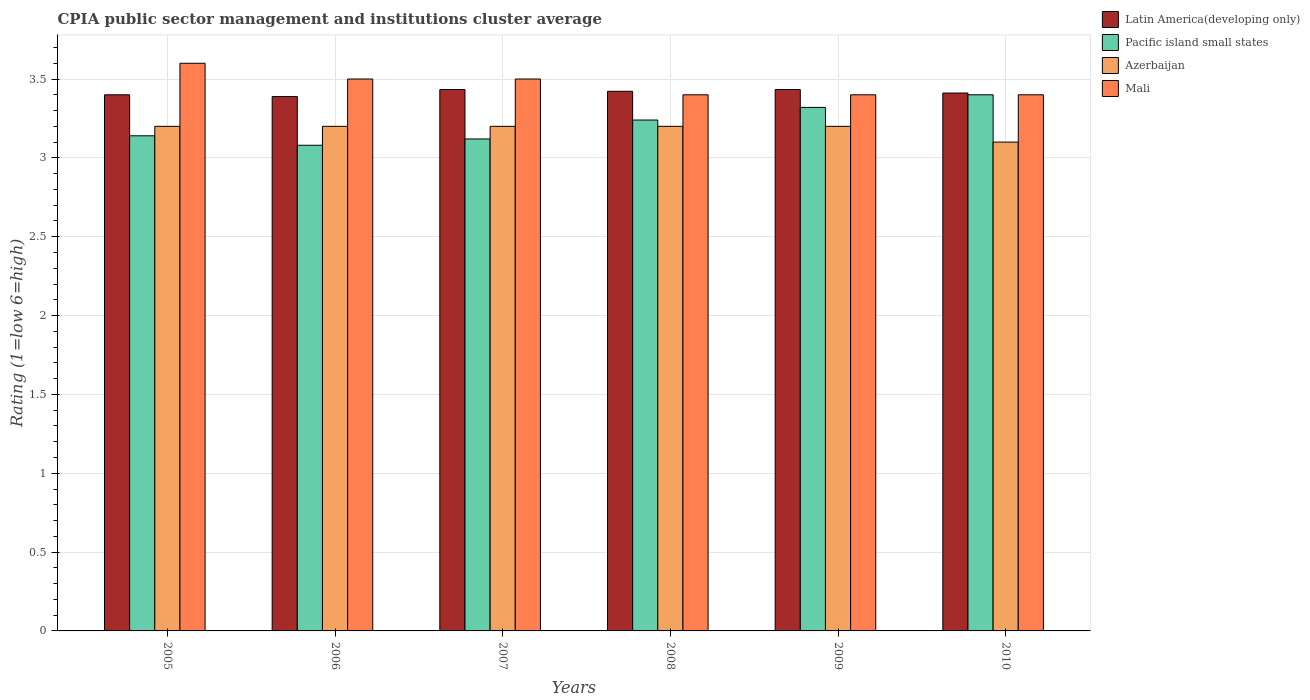How many different coloured bars are there?
Provide a short and direct response. 4. How many groups of bars are there?
Make the answer very short. 6. Are the number of bars on each tick of the X-axis equal?
Your response must be concise. Yes. What is the label of the 1st group of bars from the left?
Your answer should be compact. 2005. In how many cases, is the number of bars for a given year not equal to the number of legend labels?
Your answer should be very brief. 0. What is the CPIA rating in Pacific island small states in 2005?
Offer a very short reply. 3.14. Across all years, what is the maximum CPIA rating in Latin America(developing only)?
Provide a succinct answer. 3.43. Across all years, what is the minimum CPIA rating in Pacific island small states?
Your answer should be very brief. 3.08. In which year was the CPIA rating in Azerbaijan maximum?
Your answer should be very brief. 2005. In which year was the CPIA rating in Mali minimum?
Provide a succinct answer. 2008. What is the total CPIA rating in Latin America(developing only) in the graph?
Your answer should be very brief. 20.49. What is the difference between the CPIA rating in Mali in 2007 and that in 2010?
Provide a short and direct response. 0.1. What is the difference between the CPIA rating in Azerbaijan in 2008 and the CPIA rating in Latin America(developing only) in 2010?
Offer a very short reply. -0.21. What is the average CPIA rating in Latin America(developing only) per year?
Your answer should be compact. 3.41. In the year 2008, what is the difference between the CPIA rating in Latin America(developing only) and CPIA rating in Pacific island small states?
Keep it short and to the point. 0.18. In how many years, is the CPIA rating in Mali greater than 0.1?
Provide a short and direct response. 6. What is the ratio of the CPIA rating in Pacific island small states in 2005 to that in 2008?
Give a very brief answer. 0.97. Is the CPIA rating in Pacific island small states in 2006 less than that in 2010?
Provide a short and direct response. Yes. Is the difference between the CPIA rating in Latin America(developing only) in 2008 and 2010 greater than the difference between the CPIA rating in Pacific island small states in 2008 and 2010?
Your answer should be very brief. Yes. What is the difference between the highest and the second highest CPIA rating in Mali?
Offer a terse response. 0.1. What is the difference between the highest and the lowest CPIA rating in Latin America(developing only)?
Your answer should be very brief. 0.04. In how many years, is the CPIA rating in Pacific island small states greater than the average CPIA rating in Pacific island small states taken over all years?
Your response must be concise. 3. Is it the case that in every year, the sum of the CPIA rating in Mali and CPIA rating in Pacific island small states is greater than the sum of CPIA rating in Latin America(developing only) and CPIA rating in Azerbaijan?
Give a very brief answer. No. What does the 4th bar from the left in 2009 represents?
Give a very brief answer. Mali. What does the 2nd bar from the right in 2010 represents?
Provide a succinct answer. Azerbaijan. How many bars are there?
Make the answer very short. 24. Are all the bars in the graph horizontal?
Give a very brief answer. No. How many years are there in the graph?
Offer a terse response. 6. What is the difference between two consecutive major ticks on the Y-axis?
Keep it short and to the point. 0.5. How are the legend labels stacked?
Ensure brevity in your answer.  Vertical. What is the title of the graph?
Ensure brevity in your answer.  CPIA public sector management and institutions cluster average. What is the label or title of the X-axis?
Ensure brevity in your answer.  Years. What is the label or title of the Y-axis?
Offer a very short reply. Rating (1=low 6=high). What is the Rating (1=low 6=high) of Latin America(developing only) in 2005?
Your answer should be compact. 3.4. What is the Rating (1=low 6=high) of Pacific island small states in 2005?
Provide a short and direct response. 3.14. What is the Rating (1=low 6=high) of Latin America(developing only) in 2006?
Your answer should be compact. 3.39. What is the Rating (1=low 6=high) in Pacific island small states in 2006?
Ensure brevity in your answer.  3.08. What is the Rating (1=low 6=high) in Latin America(developing only) in 2007?
Your response must be concise. 3.43. What is the Rating (1=low 6=high) of Pacific island small states in 2007?
Provide a short and direct response. 3.12. What is the Rating (1=low 6=high) in Latin America(developing only) in 2008?
Your answer should be compact. 3.42. What is the Rating (1=low 6=high) in Pacific island small states in 2008?
Provide a succinct answer. 3.24. What is the Rating (1=low 6=high) in Azerbaijan in 2008?
Give a very brief answer. 3.2. What is the Rating (1=low 6=high) in Latin America(developing only) in 2009?
Offer a terse response. 3.43. What is the Rating (1=low 6=high) in Pacific island small states in 2009?
Offer a terse response. 3.32. What is the Rating (1=low 6=high) of Azerbaijan in 2009?
Offer a terse response. 3.2. What is the Rating (1=low 6=high) of Latin America(developing only) in 2010?
Your answer should be very brief. 3.41. What is the Rating (1=low 6=high) of Pacific island small states in 2010?
Make the answer very short. 3.4. What is the Rating (1=low 6=high) of Azerbaijan in 2010?
Offer a terse response. 3.1. What is the Rating (1=low 6=high) in Mali in 2010?
Offer a terse response. 3.4. Across all years, what is the maximum Rating (1=low 6=high) of Latin America(developing only)?
Give a very brief answer. 3.43. Across all years, what is the maximum Rating (1=low 6=high) of Azerbaijan?
Offer a terse response. 3.2. Across all years, what is the minimum Rating (1=low 6=high) of Latin America(developing only)?
Your answer should be very brief. 3.39. Across all years, what is the minimum Rating (1=low 6=high) in Pacific island small states?
Offer a very short reply. 3.08. Across all years, what is the minimum Rating (1=low 6=high) of Azerbaijan?
Provide a succinct answer. 3.1. What is the total Rating (1=low 6=high) of Latin America(developing only) in the graph?
Your answer should be very brief. 20.49. What is the total Rating (1=low 6=high) of Pacific island small states in the graph?
Provide a succinct answer. 19.3. What is the total Rating (1=low 6=high) of Mali in the graph?
Offer a terse response. 20.8. What is the difference between the Rating (1=low 6=high) of Latin America(developing only) in 2005 and that in 2006?
Make the answer very short. 0.01. What is the difference between the Rating (1=low 6=high) in Pacific island small states in 2005 and that in 2006?
Keep it short and to the point. 0.06. What is the difference between the Rating (1=low 6=high) in Latin America(developing only) in 2005 and that in 2007?
Give a very brief answer. -0.03. What is the difference between the Rating (1=low 6=high) of Pacific island small states in 2005 and that in 2007?
Ensure brevity in your answer.  0.02. What is the difference between the Rating (1=low 6=high) in Azerbaijan in 2005 and that in 2007?
Provide a short and direct response. 0. What is the difference between the Rating (1=low 6=high) in Mali in 2005 and that in 2007?
Offer a terse response. 0.1. What is the difference between the Rating (1=low 6=high) in Latin America(developing only) in 2005 and that in 2008?
Your response must be concise. -0.02. What is the difference between the Rating (1=low 6=high) in Pacific island small states in 2005 and that in 2008?
Offer a very short reply. -0.1. What is the difference between the Rating (1=low 6=high) of Azerbaijan in 2005 and that in 2008?
Give a very brief answer. 0. What is the difference between the Rating (1=low 6=high) of Mali in 2005 and that in 2008?
Offer a very short reply. 0.2. What is the difference between the Rating (1=low 6=high) in Latin America(developing only) in 2005 and that in 2009?
Keep it short and to the point. -0.03. What is the difference between the Rating (1=low 6=high) of Pacific island small states in 2005 and that in 2009?
Your answer should be very brief. -0.18. What is the difference between the Rating (1=low 6=high) in Azerbaijan in 2005 and that in 2009?
Give a very brief answer. 0. What is the difference between the Rating (1=low 6=high) in Latin America(developing only) in 2005 and that in 2010?
Your answer should be compact. -0.01. What is the difference between the Rating (1=low 6=high) in Pacific island small states in 2005 and that in 2010?
Offer a very short reply. -0.26. What is the difference between the Rating (1=low 6=high) of Azerbaijan in 2005 and that in 2010?
Give a very brief answer. 0.1. What is the difference between the Rating (1=low 6=high) of Mali in 2005 and that in 2010?
Your answer should be compact. 0.2. What is the difference between the Rating (1=low 6=high) in Latin America(developing only) in 2006 and that in 2007?
Keep it short and to the point. -0.04. What is the difference between the Rating (1=low 6=high) of Pacific island small states in 2006 and that in 2007?
Keep it short and to the point. -0.04. What is the difference between the Rating (1=low 6=high) in Azerbaijan in 2006 and that in 2007?
Your answer should be compact. 0. What is the difference between the Rating (1=low 6=high) in Latin America(developing only) in 2006 and that in 2008?
Offer a very short reply. -0.03. What is the difference between the Rating (1=low 6=high) in Pacific island small states in 2006 and that in 2008?
Provide a succinct answer. -0.16. What is the difference between the Rating (1=low 6=high) of Mali in 2006 and that in 2008?
Provide a succinct answer. 0.1. What is the difference between the Rating (1=low 6=high) in Latin America(developing only) in 2006 and that in 2009?
Offer a very short reply. -0.04. What is the difference between the Rating (1=low 6=high) of Pacific island small states in 2006 and that in 2009?
Provide a succinct answer. -0.24. What is the difference between the Rating (1=low 6=high) in Azerbaijan in 2006 and that in 2009?
Give a very brief answer. 0. What is the difference between the Rating (1=low 6=high) of Latin America(developing only) in 2006 and that in 2010?
Provide a short and direct response. -0.02. What is the difference between the Rating (1=low 6=high) of Pacific island small states in 2006 and that in 2010?
Ensure brevity in your answer.  -0.32. What is the difference between the Rating (1=low 6=high) of Latin America(developing only) in 2007 and that in 2008?
Provide a short and direct response. 0.01. What is the difference between the Rating (1=low 6=high) in Pacific island small states in 2007 and that in 2008?
Your response must be concise. -0.12. What is the difference between the Rating (1=low 6=high) of Mali in 2007 and that in 2008?
Provide a succinct answer. 0.1. What is the difference between the Rating (1=low 6=high) in Latin America(developing only) in 2007 and that in 2009?
Provide a succinct answer. 0. What is the difference between the Rating (1=low 6=high) in Mali in 2007 and that in 2009?
Ensure brevity in your answer.  0.1. What is the difference between the Rating (1=low 6=high) in Latin America(developing only) in 2007 and that in 2010?
Ensure brevity in your answer.  0.02. What is the difference between the Rating (1=low 6=high) in Pacific island small states in 2007 and that in 2010?
Keep it short and to the point. -0.28. What is the difference between the Rating (1=low 6=high) in Mali in 2007 and that in 2010?
Your response must be concise. 0.1. What is the difference between the Rating (1=low 6=high) in Latin America(developing only) in 2008 and that in 2009?
Ensure brevity in your answer.  -0.01. What is the difference between the Rating (1=low 6=high) in Pacific island small states in 2008 and that in 2009?
Provide a short and direct response. -0.08. What is the difference between the Rating (1=low 6=high) of Latin America(developing only) in 2008 and that in 2010?
Your answer should be very brief. 0.01. What is the difference between the Rating (1=low 6=high) of Pacific island small states in 2008 and that in 2010?
Your answer should be very brief. -0.16. What is the difference between the Rating (1=low 6=high) of Azerbaijan in 2008 and that in 2010?
Keep it short and to the point. 0.1. What is the difference between the Rating (1=low 6=high) in Latin America(developing only) in 2009 and that in 2010?
Your response must be concise. 0.02. What is the difference between the Rating (1=low 6=high) in Pacific island small states in 2009 and that in 2010?
Give a very brief answer. -0.08. What is the difference between the Rating (1=low 6=high) of Latin America(developing only) in 2005 and the Rating (1=low 6=high) of Pacific island small states in 2006?
Provide a succinct answer. 0.32. What is the difference between the Rating (1=low 6=high) in Latin America(developing only) in 2005 and the Rating (1=low 6=high) in Azerbaijan in 2006?
Offer a terse response. 0.2. What is the difference between the Rating (1=low 6=high) in Latin America(developing only) in 2005 and the Rating (1=low 6=high) in Mali in 2006?
Provide a short and direct response. -0.1. What is the difference between the Rating (1=low 6=high) of Pacific island small states in 2005 and the Rating (1=low 6=high) of Azerbaijan in 2006?
Keep it short and to the point. -0.06. What is the difference between the Rating (1=low 6=high) in Pacific island small states in 2005 and the Rating (1=low 6=high) in Mali in 2006?
Keep it short and to the point. -0.36. What is the difference between the Rating (1=low 6=high) of Latin America(developing only) in 2005 and the Rating (1=low 6=high) of Pacific island small states in 2007?
Provide a short and direct response. 0.28. What is the difference between the Rating (1=low 6=high) of Latin America(developing only) in 2005 and the Rating (1=low 6=high) of Mali in 2007?
Provide a succinct answer. -0.1. What is the difference between the Rating (1=low 6=high) in Pacific island small states in 2005 and the Rating (1=low 6=high) in Azerbaijan in 2007?
Give a very brief answer. -0.06. What is the difference between the Rating (1=low 6=high) of Pacific island small states in 2005 and the Rating (1=low 6=high) of Mali in 2007?
Provide a short and direct response. -0.36. What is the difference between the Rating (1=low 6=high) in Azerbaijan in 2005 and the Rating (1=low 6=high) in Mali in 2007?
Make the answer very short. -0.3. What is the difference between the Rating (1=low 6=high) of Latin America(developing only) in 2005 and the Rating (1=low 6=high) of Pacific island small states in 2008?
Your response must be concise. 0.16. What is the difference between the Rating (1=low 6=high) in Pacific island small states in 2005 and the Rating (1=low 6=high) in Azerbaijan in 2008?
Provide a short and direct response. -0.06. What is the difference between the Rating (1=low 6=high) of Pacific island small states in 2005 and the Rating (1=low 6=high) of Mali in 2008?
Provide a short and direct response. -0.26. What is the difference between the Rating (1=low 6=high) of Latin America(developing only) in 2005 and the Rating (1=low 6=high) of Pacific island small states in 2009?
Give a very brief answer. 0.08. What is the difference between the Rating (1=low 6=high) of Latin America(developing only) in 2005 and the Rating (1=low 6=high) of Mali in 2009?
Keep it short and to the point. 0. What is the difference between the Rating (1=low 6=high) in Pacific island small states in 2005 and the Rating (1=low 6=high) in Azerbaijan in 2009?
Offer a terse response. -0.06. What is the difference between the Rating (1=low 6=high) of Pacific island small states in 2005 and the Rating (1=low 6=high) of Mali in 2009?
Make the answer very short. -0.26. What is the difference between the Rating (1=low 6=high) of Latin America(developing only) in 2005 and the Rating (1=low 6=high) of Pacific island small states in 2010?
Your answer should be very brief. 0. What is the difference between the Rating (1=low 6=high) of Latin America(developing only) in 2005 and the Rating (1=low 6=high) of Azerbaijan in 2010?
Offer a terse response. 0.3. What is the difference between the Rating (1=low 6=high) in Pacific island small states in 2005 and the Rating (1=low 6=high) in Azerbaijan in 2010?
Your answer should be compact. 0.04. What is the difference between the Rating (1=low 6=high) in Pacific island small states in 2005 and the Rating (1=low 6=high) in Mali in 2010?
Your response must be concise. -0.26. What is the difference between the Rating (1=low 6=high) in Azerbaijan in 2005 and the Rating (1=low 6=high) in Mali in 2010?
Keep it short and to the point. -0.2. What is the difference between the Rating (1=low 6=high) in Latin America(developing only) in 2006 and the Rating (1=low 6=high) in Pacific island small states in 2007?
Ensure brevity in your answer.  0.27. What is the difference between the Rating (1=low 6=high) of Latin America(developing only) in 2006 and the Rating (1=low 6=high) of Azerbaijan in 2007?
Provide a succinct answer. 0.19. What is the difference between the Rating (1=low 6=high) of Latin America(developing only) in 2006 and the Rating (1=low 6=high) of Mali in 2007?
Your answer should be compact. -0.11. What is the difference between the Rating (1=low 6=high) of Pacific island small states in 2006 and the Rating (1=low 6=high) of Azerbaijan in 2007?
Your response must be concise. -0.12. What is the difference between the Rating (1=low 6=high) in Pacific island small states in 2006 and the Rating (1=low 6=high) in Mali in 2007?
Provide a succinct answer. -0.42. What is the difference between the Rating (1=low 6=high) in Latin America(developing only) in 2006 and the Rating (1=low 6=high) in Pacific island small states in 2008?
Offer a terse response. 0.15. What is the difference between the Rating (1=low 6=high) in Latin America(developing only) in 2006 and the Rating (1=low 6=high) in Azerbaijan in 2008?
Your response must be concise. 0.19. What is the difference between the Rating (1=low 6=high) in Latin America(developing only) in 2006 and the Rating (1=low 6=high) in Mali in 2008?
Make the answer very short. -0.01. What is the difference between the Rating (1=low 6=high) of Pacific island small states in 2006 and the Rating (1=low 6=high) of Azerbaijan in 2008?
Your answer should be very brief. -0.12. What is the difference between the Rating (1=low 6=high) of Pacific island small states in 2006 and the Rating (1=low 6=high) of Mali in 2008?
Keep it short and to the point. -0.32. What is the difference between the Rating (1=low 6=high) in Azerbaijan in 2006 and the Rating (1=low 6=high) in Mali in 2008?
Offer a very short reply. -0.2. What is the difference between the Rating (1=low 6=high) of Latin America(developing only) in 2006 and the Rating (1=low 6=high) of Pacific island small states in 2009?
Offer a terse response. 0.07. What is the difference between the Rating (1=low 6=high) in Latin America(developing only) in 2006 and the Rating (1=low 6=high) in Azerbaijan in 2009?
Your answer should be very brief. 0.19. What is the difference between the Rating (1=low 6=high) in Latin America(developing only) in 2006 and the Rating (1=low 6=high) in Mali in 2009?
Ensure brevity in your answer.  -0.01. What is the difference between the Rating (1=low 6=high) of Pacific island small states in 2006 and the Rating (1=low 6=high) of Azerbaijan in 2009?
Provide a succinct answer. -0.12. What is the difference between the Rating (1=low 6=high) of Pacific island small states in 2006 and the Rating (1=low 6=high) of Mali in 2009?
Your answer should be compact. -0.32. What is the difference between the Rating (1=low 6=high) in Azerbaijan in 2006 and the Rating (1=low 6=high) in Mali in 2009?
Ensure brevity in your answer.  -0.2. What is the difference between the Rating (1=low 6=high) of Latin America(developing only) in 2006 and the Rating (1=low 6=high) of Pacific island small states in 2010?
Ensure brevity in your answer.  -0.01. What is the difference between the Rating (1=low 6=high) of Latin America(developing only) in 2006 and the Rating (1=low 6=high) of Azerbaijan in 2010?
Offer a very short reply. 0.29. What is the difference between the Rating (1=low 6=high) in Latin America(developing only) in 2006 and the Rating (1=low 6=high) in Mali in 2010?
Provide a succinct answer. -0.01. What is the difference between the Rating (1=low 6=high) of Pacific island small states in 2006 and the Rating (1=low 6=high) of Azerbaijan in 2010?
Keep it short and to the point. -0.02. What is the difference between the Rating (1=low 6=high) in Pacific island small states in 2006 and the Rating (1=low 6=high) in Mali in 2010?
Your answer should be compact. -0.32. What is the difference between the Rating (1=low 6=high) of Azerbaijan in 2006 and the Rating (1=low 6=high) of Mali in 2010?
Make the answer very short. -0.2. What is the difference between the Rating (1=low 6=high) of Latin America(developing only) in 2007 and the Rating (1=low 6=high) of Pacific island small states in 2008?
Your answer should be compact. 0.19. What is the difference between the Rating (1=low 6=high) in Latin America(developing only) in 2007 and the Rating (1=low 6=high) in Azerbaijan in 2008?
Offer a terse response. 0.23. What is the difference between the Rating (1=low 6=high) in Pacific island small states in 2007 and the Rating (1=low 6=high) in Azerbaijan in 2008?
Provide a short and direct response. -0.08. What is the difference between the Rating (1=low 6=high) of Pacific island small states in 2007 and the Rating (1=low 6=high) of Mali in 2008?
Keep it short and to the point. -0.28. What is the difference between the Rating (1=low 6=high) of Latin America(developing only) in 2007 and the Rating (1=low 6=high) of Pacific island small states in 2009?
Your response must be concise. 0.11. What is the difference between the Rating (1=low 6=high) in Latin America(developing only) in 2007 and the Rating (1=low 6=high) in Azerbaijan in 2009?
Provide a short and direct response. 0.23. What is the difference between the Rating (1=low 6=high) of Pacific island small states in 2007 and the Rating (1=low 6=high) of Azerbaijan in 2009?
Provide a succinct answer. -0.08. What is the difference between the Rating (1=low 6=high) in Pacific island small states in 2007 and the Rating (1=low 6=high) in Mali in 2009?
Provide a succinct answer. -0.28. What is the difference between the Rating (1=low 6=high) in Latin America(developing only) in 2007 and the Rating (1=low 6=high) in Pacific island small states in 2010?
Make the answer very short. 0.03. What is the difference between the Rating (1=low 6=high) in Pacific island small states in 2007 and the Rating (1=low 6=high) in Azerbaijan in 2010?
Your answer should be compact. 0.02. What is the difference between the Rating (1=low 6=high) of Pacific island small states in 2007 and the Rating (1=low 6=high) of Mali in 2010?
Offer a very short reply. -0.28. What is the difference between the Rating (1=low 6=high) in Latin America(developing only) in 2008 and the Rating (1=low 6=high) in Pacific island small states in 2009?
Give a very brief answer. 0.1. What is the difference between the Rating (1=low 6=high) of Latin America(developing only) in 2008 and the Rating (1=low 6=high) of Azerbaijan in 2009?
Your answer should be very brief. 0.22. What is the difference between the Rating (1=low 6=high) of Latin America(developing only) in 2008 and the Rating (1=low 6=high) of Mali in 2009?
Give a very brief answer. 0.02. What is the difference between the Rating (1=low 6=high) of Pacific island small states in 2008 and the Rating (1=low 6=high) of Azerbaijan in 2009?
Your answer should be very brief. 0.04. What is the difference between the Rating (1=low 6=high) in Pacific island small states in 2008 and the Rating (1=low 6=high) in Mali in 2009?
Provide a succinct answer. -0.16. What is the difference between the Rating (1=low 6=high) in Azerbaijan in 2008 and the Rating (1=low 6=high) in Mali in 2009?
Ensure brevity in your answer.  -0.2. What is the difference between the Rating (1=low 6=high) of Latin America(developing only) in 2008 and the Rating (1=low 6=high) of Pacific island small states in 2010?
Make the answer very short. 0.02. What is the difference between the Rating (1=low 6=high) of Latin America(developing only) in 2008 and the Rating (1=low 6=high) of Azerbaijan in 2010?
Your answer should be compact. 0.32. What is the difference between the Rating (1=low 6=high) in Latin America(developing only) in 2008 and the Rating (1=low 6=high) in Mali in 2010?
Keep it short and to the point. 0.02. What is the difference between the Rating (1=low 6=high) of Pacific island small states in 2008 and the Rating (1=low 6=high) of Azerbaijan in 2010?
Give a very brief answer. 0.14. What is the difference between the Rating (1=low 6=high) in Pacific island small states in 2008 and the Rating (1=low 6=high) in Mali in 2010?
Offer a terse response. -0.16. What is the difference between the Rating (1=low 6=high) of Latin America(developing only) in 2009 and the Rating (1=low 6=high) of Azerbaijan in 2010?
Provide a succinct answer. 0.33. What is the difference between the Rating (1=low 6=high) in Pacific island small states in 2009 and the Rating (1=low 6=high) in Azerbaijan in 2010?
Make the answer very short. 0.22. What is the difference between the Rating (1=low 6=high) of Pacific island small states in 2009 and the Rating (1=low 6=high) of Mali in 2010?
Give a very brief answer. -0.08. What is the average Rating (1=low 6=high) of Latin America(developing only) per year?
Make the answer very short. 3.41. What is the average Rating (1=low 6=high) in Pacific island small states per year?
Give a very brief answer. 3.22. What is the average Rating (1=low 6=high) in Azerbaijan per year?
Give a very brief answer. 3.18. What is the average Rating (1=low 6=high) in Mali per year?
Offer a very short reply. 3.47. In the year 2005, what is the difference between the Rating (1=low 6=high) of Latin America(developing only) and Rating (1=low 6=high) of Pacific island small states?
Ensure brevity in your answer.  0.26. In the year 2005, what is the difference between the Rating (1=low 6=high) in Latin America(developing only) and Rating (1=low 6=high) in Azerbaijan?
Your response must be concise. 0.2. In the year 2005, what is the difference between the Rating (1=low 6=high) of Latin America(developing only) and Rating (1=low 6=high) of Mali?
Your answer should be compact. -0.2. In the year 2005, what is the difference between the Rating (1=low 6=high) of Pacific island small states and Rating (1=low 6=high) of Azerbaijan?
Give a very brief answer. -0.06. In the year 2005, what is the difference between the Rating (1=low 6=high) of Pacific island small states and Rating (1=low 6=high) of Mali?
Offer a terse response. -0.46. In the year 2006, what is the difference between the Rating (1=low 6=high) in Latin America(developing only) and Rating (1=low 6=high) in Pacific island small states?
Your answer should be very brief. 0.31. In the year 2006, what is the difference between the Rating (1=low 6=high) in Latin America(developing only) and Rating (1=low 6=high) in Azerbaijan?
Your response must be concise. 0.19. In the year 2006, what is the difference between the Rating (1=low 6=high) of Latin America(developing only) and Rating (1=low 6=high) of Mali?
Provide a short and direct response. -0.11. In the year 2006, what is the difference between the Rating (1=low 6=high) of Pacific island small states and Rating (1=low 6=high) of Azerbaijan?
Give a very brief answer. -0.12. In the year 2006, what is the difference between the Rating (1=low 6=high) in Pacific island small states and Rating (1=low 6=high) in Mali?
Keep it short and to the point. -0.42. In the year 2006, what is the difference between the Rating (1=low 6=high) of Azerbaijan and Rating (1=low 6=high) of Mali?
Your answer should be very brief. -0.3. In the year 2007, what is the difference between the Rating (1=low 6=high) in Latin America(developing only) and Rating (1=low 6=high) in Pacific island small states?
Keep it short and to the point. 0.31. In the year 2007, what is the difference between the Rating (1=low 6=high) in Latin America(developing only) and Rating (1=low 6=high) in Azerbaijan?
Offer a terse response. 0.23. In the year 2007, what is the difference between the Rating (1=low 6=high) of Latin America(developing only) and Rating (1=low 6=high) of Mali?
Make the answer very short. -0.07. In the year 2007, what is the difference between the Rating (1=low 6=high) in Pacific island small states and Rating (1=low 6=high) in Azerbaijan?
Offer a very short reply. -0.08. In the year 2007, what is the difference between the Rating (1=low 6=high) in Pacific island small states and Rating (1=low 6=high) in Mali?
Provide a succinct answer. -0.38. In the year 2008, what is the difference between the Rating (1=low 6=high) in Latin America(developing only) and Rating (1=low 6=high) in Pacific island small states?
Give a very brief answer. 0.18. In the year 2008, what is the difference between the Rating (1=low 6=high) of Latin America(developing only) and Rating (1=low 6=high) of Azerbaijan?
Your response must be concise. 0.22. In the year 2008, what is the difference between the Rating (1=low 6=high) of Latin America(developing only) and Rating (1=low 6=high) of Mali?
Give a very brief answer. 0.02. In the year 2008, what is the difference between the Rating (1=low 6=high) of Pacific island small states and Rating (1=low 6=high) of Azerbaijan?
Offer a terse response. 0.04. In the year 2008, what is the difference between the Rating (1=low 6=high) in Pacific island small states and Rating (1=low 6=high) in Mali?
Offer a terse response. -0.16. In the year 2008, what is the difference between the Rating (1=low 6=high) of Azerbaijan and Rating (1=low 6=high) of Mali?
Give a very brief answer. -0.2. In the year 2009, what is the difference between the Rating (1=low 6=high) of Latin America(developing only) and Rating (1=low 6=high) of Pacific island small states?
Offer a very short reply. 0.11. In the year 2009, what is the difference between the Rating (1=low 6=high) of Latin America(developing only) and Rating (1=low 6=high) of Azerbaijan?
Your answer should be very brief. 0.23. In the year 2009, what is the difference between the Rating (1=low 6=high) in Latin America(developing only) and Rating (1=low 6=high) in Mali?
Offer a very short reply. 0.03. In the year 2009, what is the difference between the Rating (1=low 6=high) in Pacific island small states and Rating (1=low 6=high) in Azerbaijan?
Your answer should be compact. 0.12. In the year 2009, what is the difference between the Rating (1=low 6=high) of Pacific island small states and Rating (1=low 6=high) of Mali?
Ensure brevity in your answer.  -0.08. In the year 2009, what is the difference between the Rating (1=low 6=high) of Azerbaijan and Rating (1=low 6=high) of Mali?
Your response must be concise. -0.2. In the year 2010, what is the difference between the Rating (1=low 6=high) of Latin America(developing only) and Rating (1=low 6=high) of Pacific island small states?
Provide a succinct answer. 0.01. In the year 2010, what is the difference between the Rating (1=low 6=high) in Latin America(developing only) and Rating (1=low 6=high) in Azerbaijan?
Ensure brevity in your answer.  0.31. In the year 2010, what is the difference between the Rating (1=low 6=high) in Latin America(developing only) and Rating (1=low 6=high) in Mali?
Your answer should be very brief. 0.01. In the year 2010, what is the difference between the Rating (1=low 6=high) of Pacific island small states and Rating (1=low 6=high) of Azerbaijan?
Your response must be concise. 0.3. In the year 2010, what is the difference between the Rating (1=low 6=high) in Azerbaijan and Rating (1=low 6=high) in Mali?
Give a very brief answer. -0.3. What is the ratio of the Rating (1=low 6=high) in Pacific island small states in 2005 to that in 2006?
Ensure brevity in your answer.  1.02. What is the ratio of the Rating (1=low 6=high) in Mali in 2005 to that in 2006?
Provide a succinct answer. 1.03. What is the ratio of the Rating (1=low 6=high) of Latin America(developing only) in 2005 to that in 2007?
Provide a succinct answer. 0.99. What is the ratio of the Rating (1=low 6=high) in Pacific island small states in 2005 to that in 2007?
Ensure brevity in your answer.  1.01. What is the ratio of the Rating (1=low 6=high) of Azerbaijan in 2005 to that in 2007?
Provide a short and direct response. 1. What is the ratio of the Rating (1=low 6=high) of Mali in 2005 to that in 2007?
Ensure brevity in your answer.  1.03. What is the ratio of the Rating (1=low 6=high) of Latin America(developing only) in 2005 to that in 2008?
Give a very brief answer. 0.99. What is the ratio of the Rating (1=low 6=high) in Pacific island small states in 2005 to that in 2008?
Offer a terse response. 0.97. What is the ratio of the Rating (1=low 6=high) in Azerbaijan in 2005 to that in 2008?
Provide a short and direct response. 1. What is the ratio of the Rating (1=low 6=high) of Mali in 2005 to that in 2008?
Give a very brief answer. 1.06. What is the ratio of the Rating (1=low 6=high) of Latin America(developing only) in 2005 to that in 2009?
Your answer should be very brief. 0.99. What is the ratio of the Rating (1=low 6=high) in Pacific island small states in 2005 to that in 2009?
Provide a succinct answer. 0.95. What is the ratio of the Rating (1=low 6=high) of Mali in 2005 to that in 2009?
Offer a very short reply. 1.06. What is the ratio of the Rating (1=low 6=high) of Latin America(developing only) in 2005 to that in 2010?
Keep it short and to the point. 1. What is the ratio of the Rating (1=low 6=high) in Pacific island small states in 2005 to that in 2010?
Your response must be concise. 0.92. What is the ratio of the Rating (1=low 6=high) of Azerbaijan in 2005 to that in 2010?
Give a very brief answer. 1.03. What is the ratio of the Rating (1=low 6=high) in Mali in 2005 to that in 2010?
Your answer should be very brief. 1.06. What is the ratio of the Rating (1=low 6=high) of Latin America(developing only) in 2006 to that in 2007?
Give a very brief answer. 0.99. What is the ratio of the Rating (1=low 6=high) in Pacific island small states in 2006 to that in 2007?
Offer a very short reply. 0.99. What is the ratio of the Rating (1=low 6=high) in Latin America(developing only) in 2006 to that in 2008?
Keep it short and to the point. 0.99. What is the ratio of the Rating (1=low 6=high) in Pacific island small states in 2006 to that in 2008?
Your response must be concise. 0.95. What is the ratio of the Rating (1=low 6=high) of Azerbaijan in 2006 to that in 2008?
Your answer should be compact. 1. What is the ratio of the Rating (1=low 6=high) in Mali in 2006 to that in 2008?
Offer a terse response. 1.03. What is the ratio of the Rating (1=low 6=high) in Latin America(developing only) in 2006 to that in 2009?
Give a very brief answer. 0.99. What is the ratio of the Rating (1=low 6=high) in Pacific island small states in 2006 to that in 2009?
Your response must be concise. 0.93. What is the ratio of the Rating (1=low 6=high) of Azerbaijan in 2006 to that in 2009?
Offer a very short reply. 1. What is the ratio of the Rating (1=low 6=high) of Mali in 2006 to that in 2009?
Your answer should be very brief. 1.03. What is the ratio of the Rating (1=low 6=high) in Latin America(developing only) in 2006 to that in 2010?
Keep it short and to the point. 0.99. What is the ratio of the Rating (1=low 6=high) of Pacific island small states in 2006 to that in 2010?
Provide a succinct answer. 0.91. What is the ratio of the Rating (1=low 6=high) of Azerbaijan in 2006 to that in 2010?
Your answer should be compact. 1.03. What is the ratio of the Rating (1=low 6=high) in Mali in 2006 to that in 2010?
Your answer should be very brief. 1.03. What is the ratio of the Rating (1=low 6=high) in Mali in 2007 to that in 2008?
Offer a terse response. 1.03. What is the ratio of the Rating (1=low 6=high) in Pacific island small states in 2007 to that in 2009?
Provide a succinct answer. 0.94. What is the ratio of the Rating (1=low 6=high) in Mali in 2007 to that in 2009?
Make the answer very short. 1.03. What is the ratio of the Rating (1=low 6=high) in Latin America(developing only) in 2007 to that in 2010?
Offer a very short reply. 1.01. What is the ratio of the Rating (1=low 6=high) in Pacific island small states in 2007 to that in 2010?
Provide a short and direct response. 0.92. What is the ratio of the Rating (1=low 6=high) of Azerbaijan in 2007 to that in 2010?
Offer a terse response. 1.03. What is the ratio of the Rating (1=low 6=high) of Mali in 2007 to that in 2010?
Give a very brief answer. 1.03. What is the ratio of the Rating (1=low 6=high) in Latin America(developing only) in 2008 to that in 2009?
Ensure brevity in your answer.  1. What is the ratio of the Rating (1=low 6=high) of Pacific island small states in 2008 to that in 2009?
Your answer should be compact. 0.98. What is the ratio of the Rating (1=low 6=high) of Mali in 2008 to that in 2009?
Give a very brief answer. 1. What is the ratio of the Rating (1=low 6=high) in Pacific island small states in 2008 to that in 2010?
Provide a short and direct response. 0.95. What is the ratio of the Rating (1=low 6=high) of Azerbaijan in 2008 to that in 2010?
Provide a short and direct response. 1.03. What is the ratio of the Rating (1=low 6=high) in Pacific island small states in 2009 to that in 2010?
Offer a terse response. 0.98. What is the ratio of the Rating (1=low 6=high) of Azerbaijan in 2009 to that in 2010?
Your answer should be very brief. 1.03. What is the difference between the highest and the lowest Rating (1=low 6=high) of Latin America(developing only)?
Give a very brief answer. 0.04. What is the difference between the highest and the lowest Rating (1=low 6=high) in Pacific island small states?
Keep it short and to the point. 0.32. What is the difference between the highest and the lowest Rating (1=low 6=high) in Mali?
Provide a succinct answer. 0.2. 